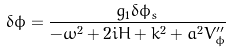<formula> <loc_0><loc_0><loc_500><loc_500>\delta \phi = \frac { g _ { 1 } \delta \phi _ { s } } { - \omega ^ { 2 } + 2 i H + k ^ { 2 } + a ^ { 2 } V ^ { \prime \prime } _ { \phi } }</formula> 